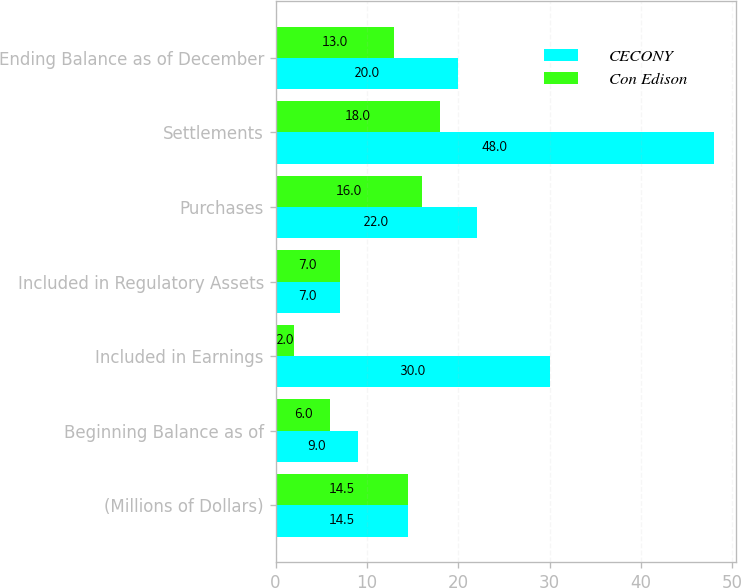Convert chart to OTSL. <chart><loc_0><loc_0><loc_500><loc_500><stacked_bar_chart><ecel><fcel>(Millions of Dollars)<fcel>Beginning Balance as of<fcel>Included in Earnings<fcel>Included in Regulatory Assets<fcel>Purchases<fcel>Settlements<fcel>Ending Balance as of December<nl><fcel>CECONY<fcel>14.5<fcel>9<fcel>30<fcel>7<fcel>22<fcel>48<fcel>20<nl><fcel>Con Edison<fcel>14.5<fcel>6<fcel>2<fcel>7<fcel>16<fcel>18<fcel>13<nl></chart> 